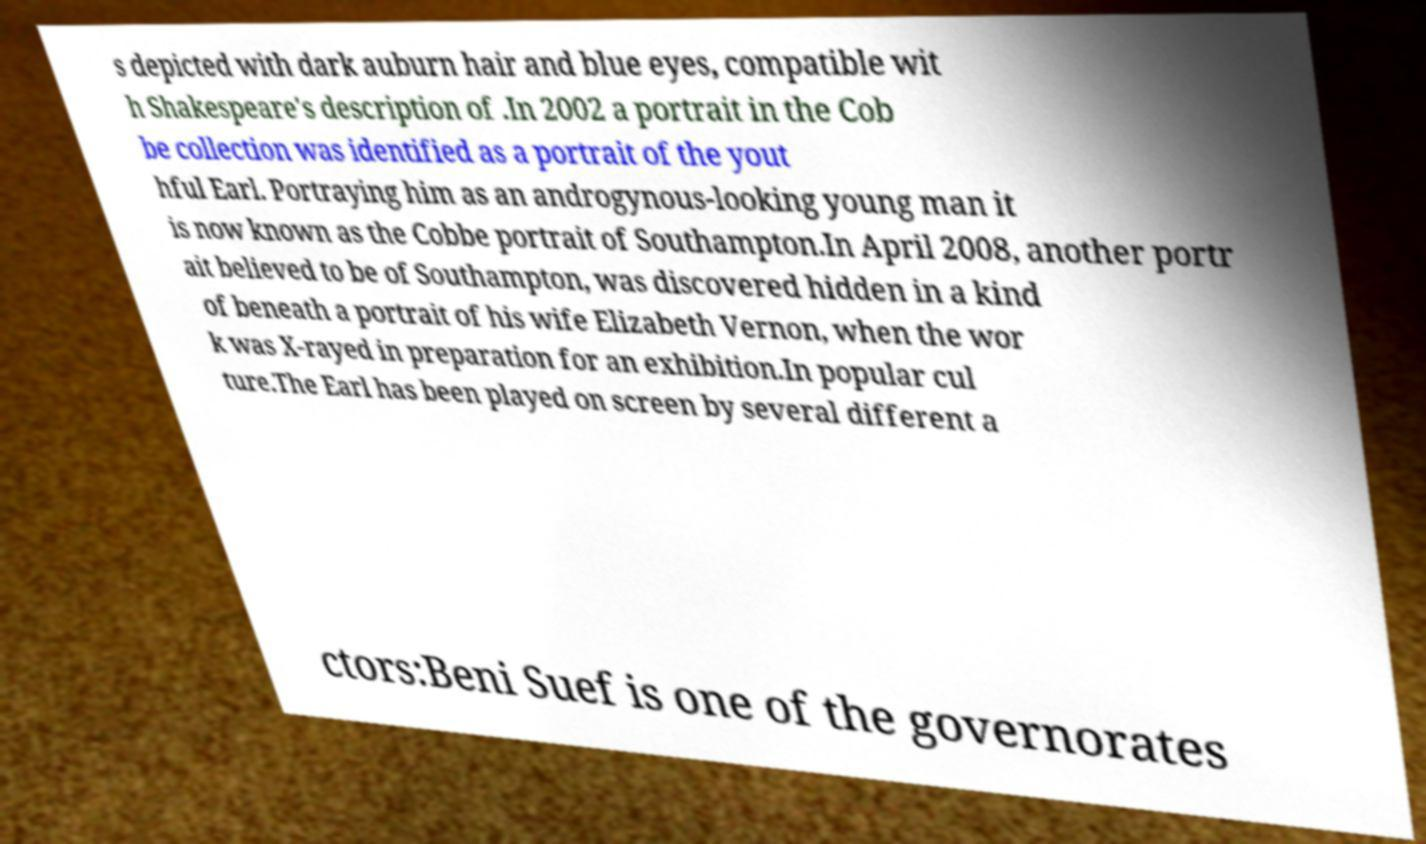Please identify and transcribe the text found in this image. s depicted with dark auburn hair and blue eyes, compatible wit h Shakespeare's description of .In 2002 a portrait in the Cob be collection was identified as a portrait of the yout hful Earl. Portraying him as an androgynous-looking young man it is now known as the Cobbe portrait of Southampton.In April 2008, another portr ait believed to be of Southampton, was discovered hidden in a kind of beneath a portrait of his wife Elizabeth Vernon, when the wor k was X-rayed in preparation for an exhibition.In popular cul ture.The Earl has been played on screen by several different a ctors:Beni Suef is one of the governorates 